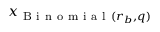Convert formula to latex. <formula><loc_0><loc_0><loc_500><loc_500>x _ { B i n o m i a l ( r _ { b } , q ) }</formula> 